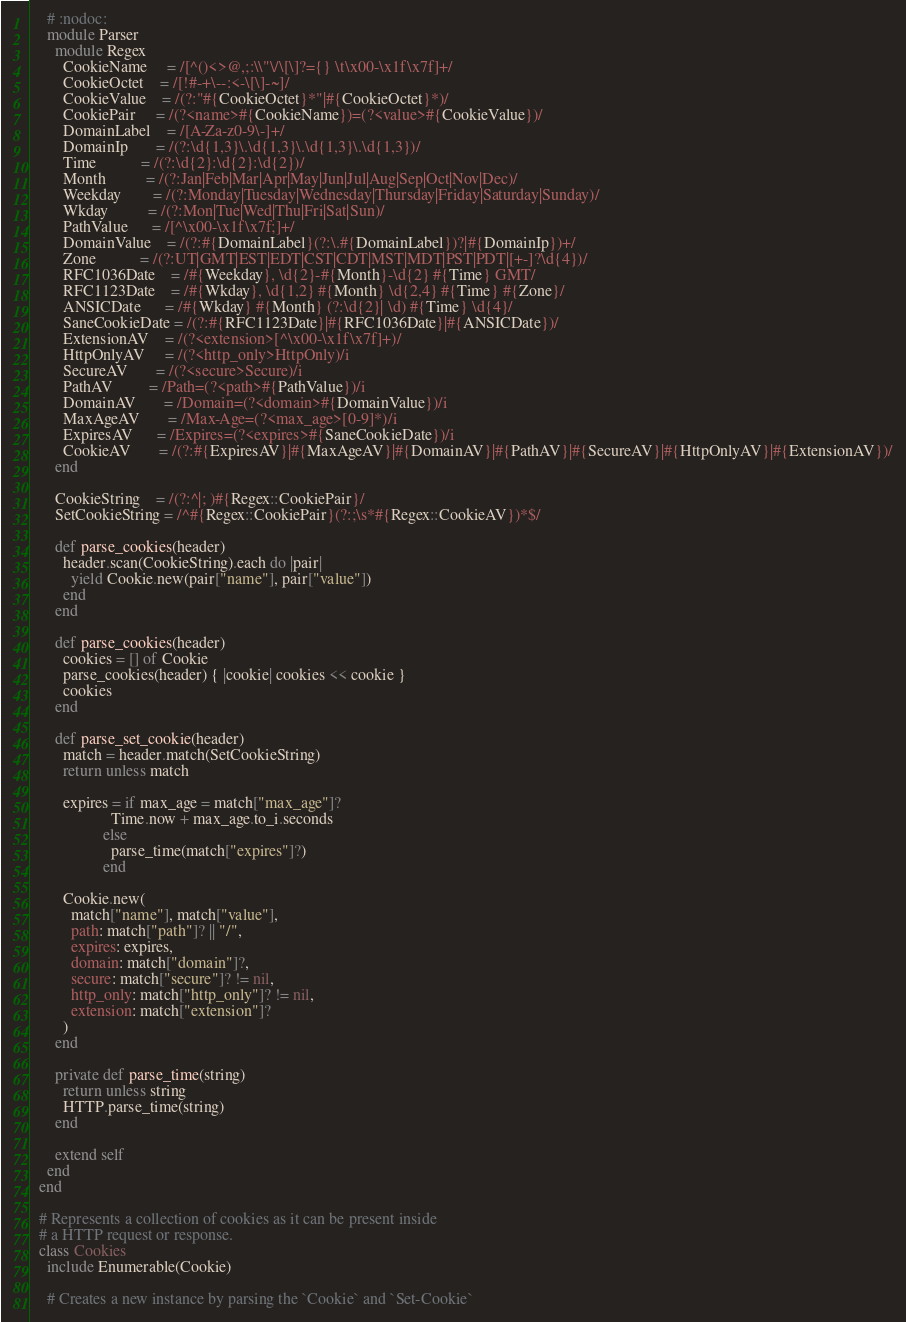<code> <loc_0><loc_0><loc_500><loc_500><_Crystal_>
    # :nodoc:
    module Parser
      module Regex
        CookieName     = /[^()<>@,;:\\"\/\[\]?={} \t\x00-\x1f\x7f]+/
        CookieOctet    = /[!#-+\--:<-\[\]-~]/
        CookieValue    = /(?:"#{CookieOctet}*"|#{CookieOctet}*)/
        CookiePair     = /(?<name>#{CookieName})=(?<value>#{CookieValue})/
        DomainLabel    = /[A-Za-z0-9\-]+/
        DomainIp       = /(?:\d{1,3}\.\d{1,3}\.\d{1,3}\.\d{1,3})/
        Time           = /(?:\d{2}:\d{2}:\d{2})/
        Month          = /(?:Jan|Feb|Mar|Apr|May|Jun|Jul|Aug|Sep|Oct|Nov|Dec)/
        Weekday        = /(?:Monday|Tuesday|Wednesday|Thursday|Friday|Saturday|Sunday)/
        Wkday          = /(?:Mon|Tue|Wed|Thu|Fri|Sat|Sun)/
        PathValue      = /[^\x00-\x1f\x7f;]+/
        DomainValue    = /(?:#{DomainLabel}(?:\.#{DomainLabel})?|#{DomainIp})+/
        Zone           = /(?:UT|GMT|EST|EDT|CST|CDT|MST|MDT|PST|PDT|[+-]?\d{4})/
        RFC1036Date    = /#{Weekday}, \d{2}-#{Month}-\d{2} #{Time} GMT/
        RFC1123Date    = /#{Wkday}, \d{1,2} #{Month} \d{2,4} #{Time} #{Zone}/
        ANSICDate      = /#{Wkday} #{Month} (?:\d{2}| \d) #{Time} \d{4}/
        SaneCookieDate = /(?:#{RFC1123Date}|#{RFC1036Date}|#{ANSICDate})/
        ExtensionAV    = /(?<extension>[^\x00-\x1f\x7f]+)/
        HttpOnlyAV     = /(?<http_only>HttpOnly)/i
        SecureAV       = /(?<secure>Secure)/i
        PathAV         = /Path=(?<path>#{PathValue})/i
        DomainAV       = /Domain=(?<domain>#{DomainValue})/i
        MaxAgeAV       = /Max-Age=(?<max_age>[0-9]*)/i
        ExpiresAV      = /Expires=(?<expires>#{SaneCookieDate})/i
        CookieAV       = /(?:#{ExpiresAV}|#{MaxAgeAV}|#{DomainAV}|#{PathAV}|#{SecureAV}|#{HttpOnlyAV}|#{ExtensionAV})/
      end

      CookieString    = /(?:^|; )#{Regex::CookiePair}/
      SetCookieString = /^#{Regex::CookiePair}(?:;\s*#{Regex::CookieAV})*$/

      def parse_cookies(header)
        header.scan(CookieString).each do |pair|
          yield Cookie.new(pair["name"], pair["value"])
        end
      end

      def parse_cookies(header)
        cookies = [] of Cookie
        parse_cookies(header) { |cookie| cookies << cookie }
        cookies
      end

      def parse_set_cookie(header)
        match = header.match(SetCookieString)
        return unless match

        expires = if max_age = match["max_age"]?
                    Time.now + max_age.to_i.seconds
                  else
                    parse_time(match["expires"]?)
                  end

        Cookie.new(
          match["name"], match["value"],
          path: match["path"]? || "/",
          expires: expires,
          domain: match["domain"]?,
          secure: match["secure"]? != nil,
          http_only: match["http_only"]? != nil,
          extension: match["extension"]?
        )
      end

      private def parse_time(string)
        return unless string
        HTTP.parse_time(string)
      end

      extend self
    end
  end

  # Represents a collection of cookies as it can be present inside
  # a HTTP request or response.
  class Cookies
    include Enumerable(Cookie)

    # Creates a new instance by parsing the `Cookie` and `Set-Cookie`</code> 